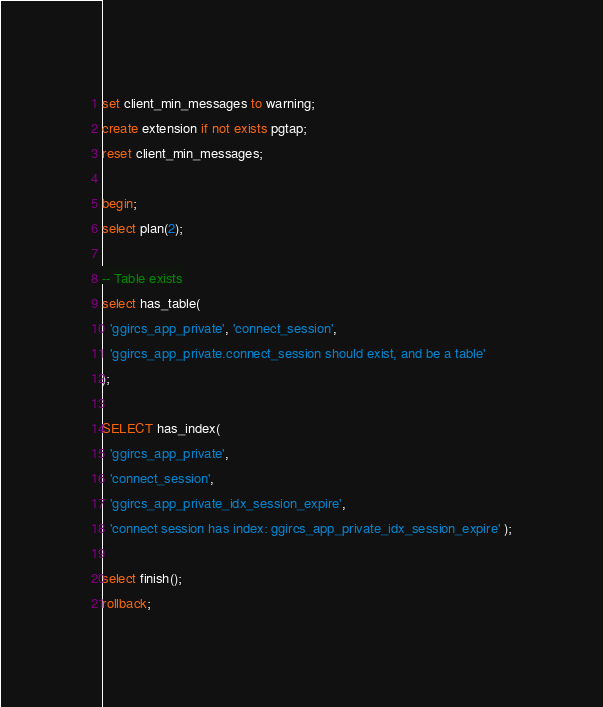Convert code to text. <code><loc_0><loc_0><loc_500><loc_500><_SQL_>set client_min_messages to warning;
create extension if not exists pgtap;
reset client_min_messages;

begin;
select plan(2);

-- Table exists
select has_table(
  'ggircs_app_private', 'connect_session',
  'ggircs_app_private.connect_session should exist, and be a table'
);

SELECT has_index(
  'ggircs_app_private',
  'connect_session',
  'ggircs_app_private_idx_session_expire',
  'connect session has index: ggircs_app_private_idx_session_expire' );

select finish();
rollback;
</code> 